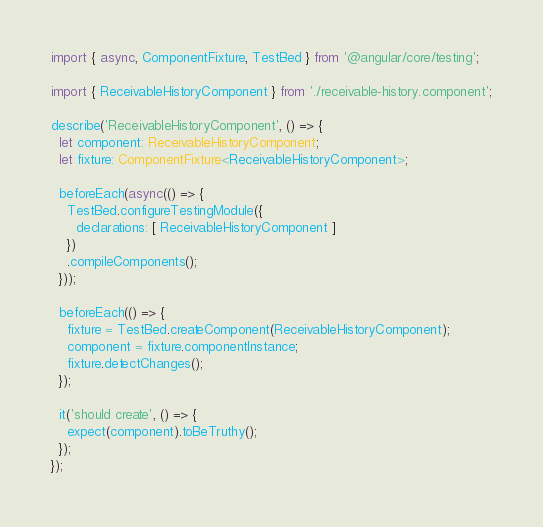<code> <loc_0><loc_0><loc_500><loc_500><_TypeScript_>import { async, ComponentFixture, TestBed } from '@angular/core/testing';

import { ReceivableHistoryComponent } from './receivable-history.component';

describe('ReceivableHistoryComponent', () => {
  let component: ReceivableHistoryComponent;
  let fixture: ComponentFixture<ReceivableHistoryComponent>;

  beforeEach(async(() => {
    TestBed.configureTestingModule({
      declarations: [ ReceivableHistoryComponent ]
    })
    .compileComponents();
  }));

  beforeEach(() => {
    fixture = TestBed.createComponent(ReceivableHistoryComponent);
    component = fixture.componentInstance;
    fixture.detectChanges();
  });

  it('should create', () => {
    expect(component).toBeTruthy();
  });
});
</code> 